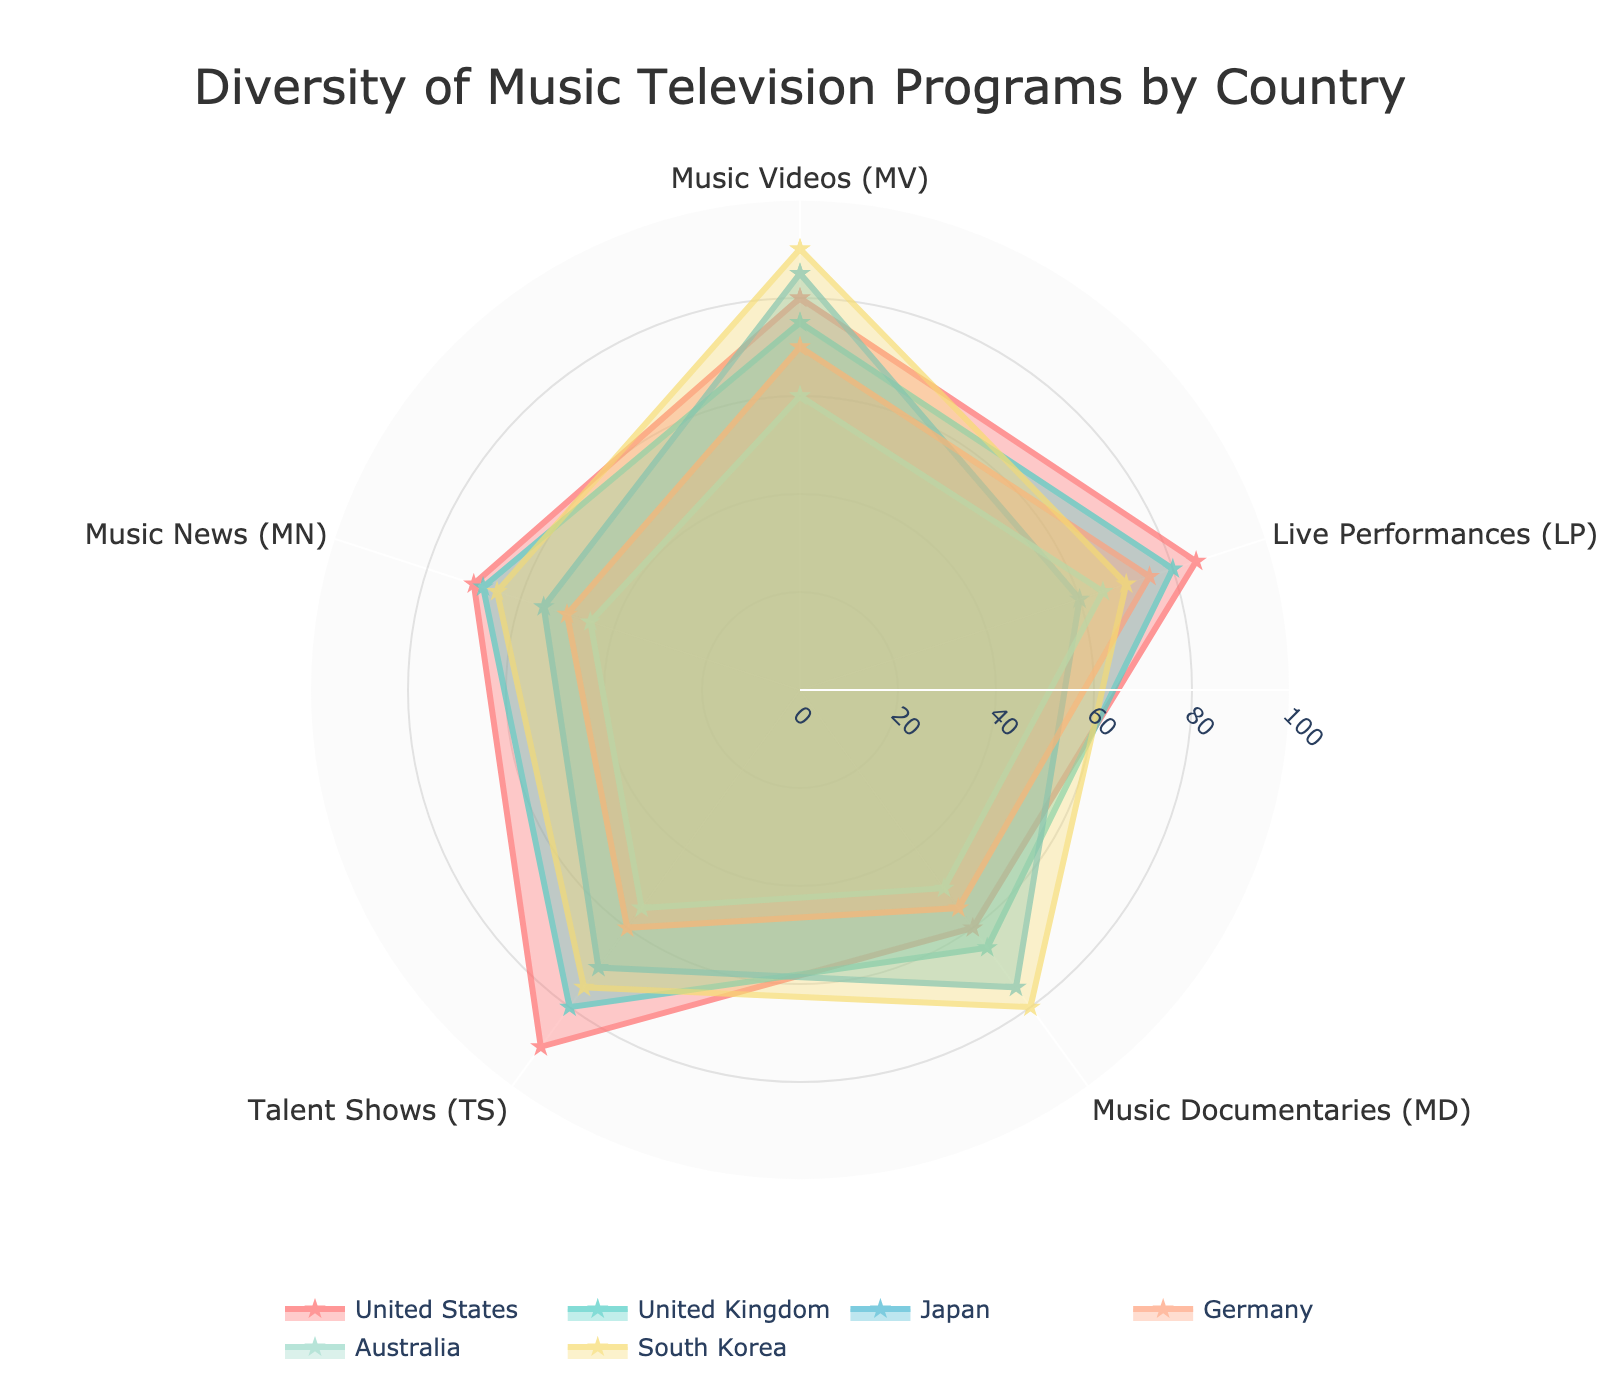What is the title of the radar chart? The title of the radar chart is written at the top of the figure.
Answer: "Diversity of Music Television Programs by Country" Which country has the highest value for Music Videos (MV)? The highest Music Videos (MV) value can be found by looking at the points associated with MV for all countries. South Korea has the highest value.
Answer: South Korea How many categories are displayed on the radar chart? The number of categories can be determined by counting the distinct points on the axis.
Answer: Five categories What is the average value of Live Performances (LP) for the United States and Japan? Add the LP values for the United States (85) and Japan (60) and divide by 2 to find the average.
Answer: 72.5 Which country shows the smallest value for Music Documentaries (MD)? The smallest MD value can be spotted at the lowest point on the MD axis for all countries, which is Australia.
Answer: Australia How do Japan and Germany compare in terms of Music News (MN)? Look at the Music News (MN) values for both Japan and Germany, and compare their sizes directly. Japan (55) has a higher MN value than Germany (50).
Answer: Japan Which country has the most balanced scores across all categories? A country is considered to have balanced scores if its values are more uniform across all categories. The United Kingdom shows relatively balanced scores when compared to others.
Answer: United Kingdom What is the difference in Talent Shows (TS) values between the United States and South Korea? Subtract the TS score of South Korea (75) from that of the United States (90).
Answer: 15 Which two countries have the closest Music Documentaries (MD) values? Find the MD values of all countries and identify the two with the smallest difference. The United Kingdom (65) and Japan (75) have the closest values.
Answer: United Kingdom and Japan Rank the countries in terms of their Music News (MN) values from highest to lowest. List all countries and their Music News (MN) values, then order them from highest to lowest. South Korea (65), United States (70), United Kingdom (68), Japan (55), Germany (50), Australia (45).
Answer: United States, United Kingdom, South Korea, Japan, Germany, Australia 